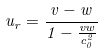Convert formula to latex. <formula><loc_0><loc_0><loc_500><loc_500>u _ { r } = \frac { v - w } { 1 - \frac { v w } { c _ { 0 } ^ { 2 } } }</formula> 